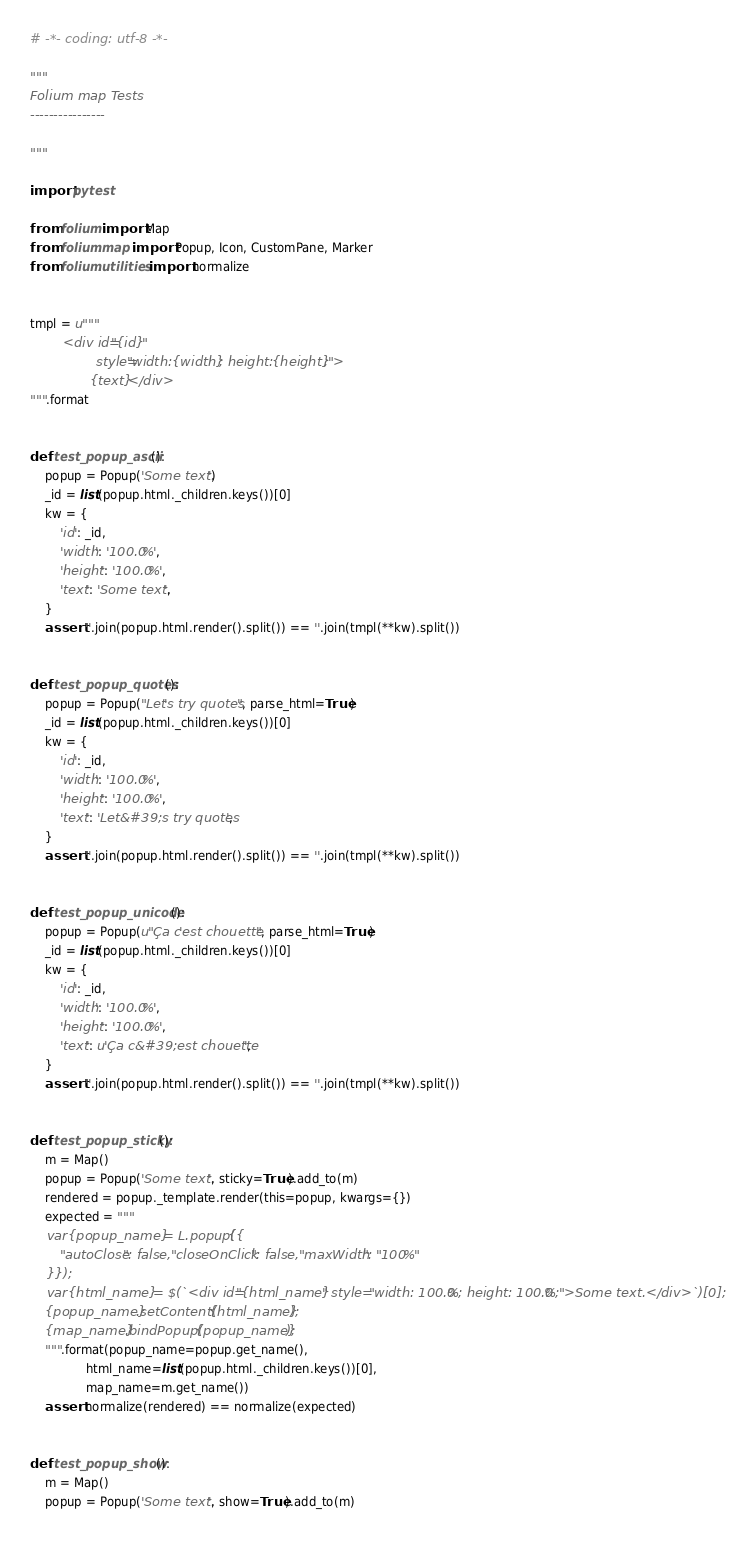<code> <loc_0><loc_0><loc_500><loc_500><_Python_># -*- coding: utf-8 -*-

"""
Folium map Tests
----------------

"""

import pytest

from folium import Map
from folium.map import Popup, Icon, CustomPane, Marker
from folium.utilities import normalize


tmpl = u"""
        <div id="{id}"
                style="width: {width}; height: {height};">
                {text}</div>
""".format


def test_popup_ascii():
    popup = Popup('Some text.')
    _id = list(popup.html._children.keys())[0]
    kw = {
        'id': _id,
        'width': '100.0%',
        'height': '100.0%',
        'text': 'Some text.',
    }
    assert ''.join(popup.html.render().split()) == ''.join(tmpl(**kw).split())


def test_popup_quotes():
    popup = Popup("Let's try quotes", parse_html=True)
    _id = list(popup.html._children.keys())[0]
    kw = {
        'id': _id,
        'width': '100.0%',
        'height': '100.0%',
        'text': 'Let&#39;s try quotes',
    }
    assert ''.join(popup.html.render().split()) == ''.join(tmpl(**kw).split())


def test_popup_unicode():
    popup = Popup(u"Ça c'est chouette", parse_html=True)
    _id = list(popup.html._children.keys())[0]
    kw = {
        'id': _id,
        'width': '100.0%',
        'height': '100.0%',
        'text': u'Ça c&#39;est chouette',
    }
    assert ''.join(popup.html.render().split()) == ''.join(tmpl(**kw).split())


def test_popup_sticky():
    m = Map()
    popup = Popup('Some text.', sticky=True).add_to(m)
    rendered = popup._template.render(this=popup, kwargs={})
    expected = """
    var {popup_name} = L.popup({{
        "autoClose": false, "closeOnClick": false, "maxWidth": "100%"
    }});
    var {html_name} = $(`<div id="{html_name}" style="width: 100.0%; height: 100.0%;">Some text.</div>`)[0];
    {popup_name}.setContent({html_name});
    {map_name}.bindPopup({popup_name});
    """.format(popup_name=popup.get_name(),
               html_name=list(popup.html._children.keys())[0],
               map_name=m.get_name())
    assert normalize(rendered) == normalize(expected)


def test_popup_show():
    m = Map()
    popup = Popup('Some text.', show=True).add_to(m)</code> 